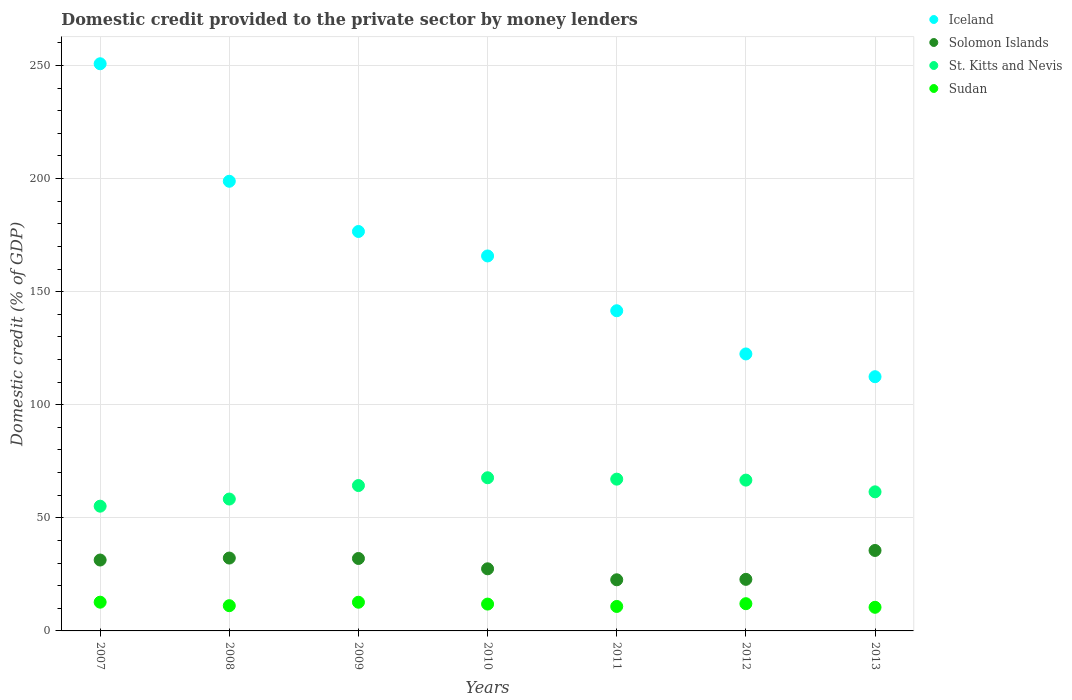Is the number of dotlines equal to the number of legend labels?
Provide a succinct answer. Yes. What is the domestic credit provided to the private sector by money lenders in Solomon Islands in 2013?
Your response must be concise. 35.57. Across all years, what is the maximum domestic credit provided to the private sector by money lenders in Iceland?
Offer a very short reply. 250.76. Across all years, what is the minimum domestic credit provided to the private sector by money lenders in Iceland?
Make the answer very short. 112.39. What is the total domestic credit provided to the private sector by money lenders in Sudan in the graph?
Your answer should be very brief. 81.71. What is the difference between the domestic credit provided to the private sector by money lenders in St. Kitts and Nevis in 2011 and that in 2012?
Offer a very short reply. 0.43. What is the difference between the domestic credit provided to the private sector by money lenders in Sudan in 2008 and the domestic credit provided to the private sector by money lenders in Solomon Islands in 2012?
Your response must be concise. -11.65. What is the average domestic credit provided to the private sector by money lenders in Sudan per year?
Your response must be concise. 11.67. In the year 2009, what is the difference between the domestic credit provided to the private sector by money lenders in St. Kitts and Nevis and domestic credit provided to the private sector by money lenders in Solomon Islands?
Give a very brief answer. 32.24. In how many years, is the domestic credit provided to the private sector by money lenders in St. Kitts and Nevis greater than 230 %?
Your answer should be very brief. 0. What is the ratio of the domestic credit provided to the private sector by money lenders in St. Kitts and Nevis in 2009 to that in 2012?
Keep it short and to the point. 0.96. Is the domestic credit provided to the private sector by money lenders in Sudan in 2010 less than that in 2012?
Your answer should be compact. Yes. Is the difference between the domestic credit provided to the private sector by money lenders in St. Kitts and Nevis in 2007 and 2012 greater than the difference between the domestic credit provided to the private sector by money lenders in Solomon Islands in 2007 and 2012?
Your response must be concise. No. What is the difference between the highest and the second highest domestic credit provided to the private sector by money lenders in Solomon Islands?
Give a very brief answer. 3.36. What is the difference between the highest and the lowest domestic credit provided to the private sector by money lenders in Solomon Islands?
Your answer should be very brief. 12.96. In how many years, is the domestic credit provided to the private sector by money lenders in St. Kitts and Nevis greater than the average domestic credit provided to the private sector by money lenders in St. Kitts and Nevis taken over all years?
Keep it short and to the point. 4. Is the sum of the domestic credit provided to the private sector by money lenders in St. Kitts and Nevis in 2008 and 2009 greater than the maximum domestic credit provided to the private sector by money lenders in Solomon Islands across all years?
Give a very brief answer. Yes. Does the domestic credit provided to the private sector by money lenders in Iceland monotonically increase over the years?
Your response must be concise. No. Is the domestic credit provided to the private sector by money lenders in Solomon Islands strictly greater than the domestic credit provided to the private sector by money lenders in St. Kitts and Nevis over the years?
Provide a short and direct response. No. What is the difference between two consecutive major ticks on the Y-axis?
Make the answer very short. 50. Does the graph contain any zero values?
Give a very brief answer. No. Where does the legend appear in the graph?
Give a very brief answer. Top right. What is the title of the graph?
Ensure brevity in your answer.  Domestic credit provided to the private sector by money lenders. What is the label or title of the Y-axis?
Keep it short and to the point. Domestic credit (% of GDP). What is the Domestic credit (% of GDP) of Iceland in 2007?
Your answer should be very brief. 250.76. What is the Domestic credit (% of GDP) of Solomon Islands in 2007?
Provide a succinct answer. 31.35. What is the Domestic credit (% of GDP) of St. Kitts and Nevis in 2007?
Provide a short and direct response. 55.15. What is the Domestic credit (% of GDP) of Sudan in 2007?
Ensure brevity in your answer.  12.71. What is the Domestic credit (% of GDP) of Iceland in 2008?
Keep it short and to the point. 198.81. What is the Domestic credit (% of GDP) in Solomon Islands in 2008?
Offer a very short reply. 32.22. What is the Domestic credit (% of GDP) in St. Kitts and Nevis in 2008?
Your response must be concise. 58.31. What is the Domestic credit (% of GDP) of Sudan in 2008?
Offer a very short reply. 11.15. What is the Domestic credit (% of GDP) in Iceland in 2009?
Your answer should be compact. 176.6. What is the Domestic credit (% of GDP) in Solomon Islands in 2009?
Provide a short and direct response. 32.03. What is the Domestic credit (% of GDP) in St. Kitts and Nevis in 2009?
Offer a terse response. 64.27. What is the Domestic credit (% of GDP) in Sudan in 2009?
Your answer should be very brief. 12.68. What is the Domestic credit (% of GDP) of Iceland in 2010?
Your answer should be compact. 165.78. What is the Domestic credit (% of GDP) in Solomon Islands in 2010?
Your response must be concise. 27.46. What is the Domestic credit (% of GDP) in St. Kitts and Nevis in 2010?
Your answer should be compact. 67.72. What is the Domestic credit (% of GDP) of Sudan in 2010?
Your answer should be very brief. 11.87. What is the Domestic credit (% of GDP) of Iceland in 2011?
Ensure brevity in your answer.  141.56. What is the Domestic credit (% of GDP) of Solomon Islands in 2011?
Provide a short and direct response. 22.61. What is the Domestic credit (% of GDP) of St. Kitts and Nevis in 2011?
Your answer should be compact. 67.1. What is the Domestic credit (% of GDP) in Sudan in 2011?
Provide a succinct answer. 10.82. What is the Domestic credit (% of GDP) in Iceland in 2012?
Your answer should be very brief. 122.46. What is the Domestic credit (% of GDP) in Solomon Islands in 2012?
Provide a short and direct response. 22.8. What is the Domestic credit (% of GDP) in St. Kitts and Nevis in 2012?
Provide a short and direct response. 66.68. What is the Domestic credit (% of GDP) of Sudan in 2012?
Make the answer very short. 12.04. What is the Domestic credit (% of GDP) in Iceland in 2013?
Ensure brevity in your answer.  112.39. What is the Domestic credit (% of GDP) in Solomon Islands in 2013?
Make the answer very short. 35.57. What is the Domestic credit (% of GDP) in St. Kitts and Nevis in 2013?
Make the answer very short. 61.49. What is the Domestic credit (% of GDP) of Sudan in 2013?
Your answer should be very brief. 10.45. Across all years, what is the maximum Domestic credit (% of GDP) in Iceland?
Make the answer very short. 250.76. Across all years, what is the maximum Domestic credit (% of GDP) in Solomon Islands?
Keep it short and to the point. 35.57. Across all years, what is the maximum Domestic credit (% of GDP) in St. Kitts and Nevis?
Keep it short and to the point. 67.72. Across all years, what is the maximum Domestic credit (% of GDP) in Sudan?
Provide a succinct answer. 12.71. Across all years, what is the minimum Domestic credit (% of GDP) in Iceland?
Offer a terse response. 112.39. Across all years, what is the minimum Domestic credit (% of GDP) in Solomon Islands?
Make the answer very short. 22.61. Across all years, what is the minimum Domestic credit (% of GDP) in St. Kitts and Nevis?
Offer a very short reply. 55.15. Across all years, what is the minimum Domestic credit (% of GDP) in Sudan?
Give a very brief answer. 10.45. What is the total Domestic credit (% of GDP) in Iceland in the graph?
Your response must be concise. 1168.37. What is the total Domestic credit (% of GDP) of Solomon Islands in the graph?
Make the answer very short. 204.04. What is the total Domestic credit (% of GDP) in St. Kitts and Nevis in the graph?
Your response must be concise. 440.72. What is the total Domestic credit (% of GDP) of Sudan in the graph?
Offer a terse response. 81.71. What is the difference between the Domestic credit (% of GDP) in Iceland in 2007 and that in 2008?
Your answer should be very brief. 51.96. What is the difference between the Domestic credit (% of GDP) of Solomon Islands in 2007 and that in 2008?
Give a very brief answer. -0.87. What is the difference between the Domestic credit (% of GDP) in St. Kitts and Nevis in 2007 and that in 2008?
Provide a short and direct response. -3.16. What is the difference between the Domestic credit (% of GDP) of Sudan in 2007 and that in 2008?
Your answer should be compact. 1.56. What is the difference between the Domestic credit (% of GDP) in Iceland in 2007 and that in 2009?
Your answer should be very brief. 74.16. What is the difference between the Domestic credit (% of GDP) of Solomon Islands in 2007 and that in 2009?
Your response must be concise. -0.68. What is the difference between the Domestic credit (% of GDP) in St. Kitts and Nevis in 2007 and that in 2009?
Make the answer very short. -9.12. What is the difference between the Domestic credit (% of GDP) in Sudan in 2007 and that in 2009?
Your answer should be compact. 0.03. What is the difference between the Domestic credit (% of GDP) of Iceland in 2007 and that in 2010?
Give a very brief answer. 84.98. What is the difference between the Domestic credit (% of GDP) of Solomon Islands in 2007 and that in 2010?
Give a very brief answer. 3.89. What is the difference between the Domestic credit (% of GDP) in St. Kitts and Nevis in 2007 and that in 2010?
Provide a short and direct response. -12.57. What is the difference between the Domestic credit (% of GDP) of Sudan in 2007 and that in 2010?
Provide a succinct answer. 0.84. What is the difference between the Domestic credit (% of GDP) in Iceland in 2007 and that in 2011?
Offer a very short reply. 109.2. What is the difference between the Domestic credit (% of GDP) in Solomon Islands in 2007 and that in 2011?
Your answer should be compact. 8.74. What is the difference between the Domestic credit (% of GDP) of St. Kitts and Nevis in 2007 and that in 2011?
Your answer should be compact. -11.95. What is the difference between the Domestic credit (% of GDP) in Sudan in 2007 and that in 2011?
Keep it short and to the point. 1.89. What is the difference between the Domestic credit (% of GDP) of Iceland in 2007 and that in 2012?
Make the answer very short. 128.3. What is the difference between the Domestic credit (% of GDP) of Solomon Islands in 2007 and that in 2012?
Give a very brief answer. 8.55. What is the difference between the Domestic credit (% of GDP) of St. Kitts and Nevis in 2007 and that in 2012?
Your answer should be very brief. -11.53. What is the difference between the Domestic credit (% of GDP) in Sudan in 2007 and that in 2012?
Ensure brevity in your answer.  0.67. What is the difference between the Domestic credit (% of GDP) of Iceland in 2007 and that in 2013?
Your answer should be compact. 138.37. What is the difference between the Domestic credit (% of GDP) of Solomon Islands in 2007 and that in 2013?
Your answer should be compact. -4.22. What is the difference between the Domestic credit (% of GDP) in St. Kitts and Nevis in 2007 and that in 2013?
Your answer should be very brief. -6.34. What is the difference between the Domestic credit (% of GDP) in Sudan in 2007 and that in 2013?
Make the answer very short. 2.26. What is the difference between the Domestic credit (% of GDP) in Iceland in 2008 and that in 2009?
Your answer should be compact. 22.2. What is the difference between the Domestic credit (% of GDP) in Solomon Islands in 2008 and that in 2009?
Offer a terse response. 0.19. What is the difference between the Domestic credit (% of GDP) in St. Kitts and Nevis in 2008 and that in 2009?
Your answer should be very brief. -5.96. What is the difference between the Domestic credit (% of GDP) in Sudan in 2008 and that in 2009?
Your response must be concise. -1.53. What is the difference between the Domestic credit (% of GDP) in Iceland in 2008 and that in 2010?
Give a very brief answer. 33.02. What is the difference between the Domestic credit (% of GDP) in Solomon Islands in 2008 and that in 2010?
Your answer should be very brief. 4.75. What is the difference between the Domestic credit (% of GDP) of St. Kitts and Nevis in 2008 and that in 2010?
Your answer should be compact. -9.41. What is the difference between the Domestic credit (% of GDP) of Sudan in 2008 and that in 2010?
Offer a very short reply. -0.71. What is the difference between the Domestic credit (% of GDP) of Iceland in 2008 and that in 2011?
Provide a short and direct response. 57.25. What is the difference between the Domestic credit (% of GDP) of Solomon Islands in 2008 and that in 2011?
Ensure brevity in your answer.  9.61. What is the difference between the Domestic credit (% of GDP) in St. Kitts and Nevis in 2008 and that in 2011?
Your answer should be compact. -8.8. What is the difference between the Domestic credit (% of GDP) of Sudan in 2008 and that in 2011?
Offer a terse response. 0.33. What is the difference between the Domestic credit (% of GDP) of Iceland in 2008 and that in 2012?
Provide a succinct answer. 76.35. What is the difference between the Domestic credit (% of GDP) of Solomon Islands in 2008 and that in 2012?
Your answer should be very brief. 9.42. What is the difference between the Domestic credit (% of GDP) of St. Kitts and Nevis in 2008 and that in 2012?
Provide a short and direct response. -8.37. What is the difference between the Domestic credit (% of GDP) in Sudan in 2008 and that in 2012?
Your answer should be very brief. -0.89. What is the difference between the Domestic credit (% of GDP) in Iceland in 2008 and that in 2013?
Offer a terse response. 86.41. What is the difference between the Domestic credit (% of GDP) of Solomon Islands in 2008 and that in 2013?
Make the answer very short. -3.36. What is the difference between the Domestic credit (% of GDP) in St. Kitts and Nevis in 2008 and that in 2013?
Your response must be concise. -3.19. What is the difference between the Domestic credit (% of GDP) of Sudan in 2008 and that in 2013?
Make the answer very short. 0.71. What is the difference between the Domestic credit (% of GDP) of Iceland in 2009 and that in 2010?
Provide a succinct answer. 10.82. What is the difference between the Domestic credit (% of GDP) of Solomon Islands in 2009 and that in 2010?
Ensure brevity in your answer.  4.57. What is the difference between the Domestic credit (% of GDP) in St. Kitts and Nevis in 2009 and that in 2010?
Keep it short and to the point. -3.45. What is the difference between the Domestic credit (% of GDP) of Sudan in 2009 and that in 2010?
Provide a succinct answer. 0.82. What is the difference between the Domestic credit (% of GDP) of Iceland in 2009 and that in 2011?
Make the answer very short. 35.04. What is the difference between the Domestic credit (% of GDP) of Solomon Islands in 2009 and that in 2011?
Give a very brief answer. 9.42. What is the difference between the Domestic credit (% of GDP) of St. Kitts and Nevis in 2009 and that in 2011?
Offer a terse response. -2.83. What is the difference between the Domestic credit (% of GDP) in Sudan in 2009 and that in 2011?
Provide a succinct answer. 1.86. What is the difference between the Domestic credit (% of GDP) in Iceland in 2009 and that in 2012?
Ensure brevity in your answer.  54.14. What is the difference between the Domestic credit (% of GDP) in Solomon Islands in 2009 and that in 2012?
Make the answer very short. 9.23. What is the difference between the Domestic credit (% of GDP) in St. Kitts and Nevis in 2009 and that in 2012?
Offer a terse response. -2.4. What is the difference between the Domestic credit (% of GDP) of Sudan in 2009 and that in 2012?
Ensure brevity in your answer.  0.64. What is the difference between the Domestic credit (% of GDP) of Iceland in 2009 and that in 2013?
Offer a very short reply. 64.21. What is the difference between the Domestic credit (% of GDP) of Solomon Islands in 2009 and that in 2013?
Provide a short and direct response. -3.54. What is the difference between the Domestic credit (% of GDP) in St. Kitts and Nevis in 2009 and that in 2013?
Make the answer very short. 2.78. What is the difference between the Domestic credit (% of GDP) in Sudan in 2009 and that in 2013?
Give a very brief answer. 2.24. What is the difference between the Domestic credit (% of GDP) of Iceland in 2010 and that in 2011?
Provide a short and direct response. 24.22. What is the difference between the Domestic credit (% of GDP) of Solomon Islands in 2010 and that in 2011?
Ensure brevity in your answer.  4.85. What is the difference between the Domestic credit (% of GDP) in St. Kitts and Nevis in 2010 and that in 2011?
Give a very brief answer. 0.61. What is the difference between the Domestic credit (% of GDP) in Sudan in 2010 and that in 2011?
Provide a succinct answer. 1.04. What is the difference between the Domestic credit (% of GDP) in Iceland in 2010 and that in 2012?
Your answer should be very brief. 43.32. What is the difference between the Domestic credit (% of GDP) in Solomon Islands in 2010 and that in 2012?
Provide a short and direct response. 4.66. What is the difference between the Domestic credit (% of GDP) in St. Kitts and Nevis in 2010 and that in 2012?
Provide a succinct answer. 1.04. What is the difference between the Domestic credit (% of GDP) of Sudan in 2010 and that in 2012?
Make the answer very short. -0.17. What is the difference between the Domestic credit (% of GDP) in Iceland in 2010 and that in 2013?
Your response must be concise. 53.39. What is the difference between the Domestic credit (% of GDP) in Solomon Islands in 2010 and that in 2013?
Your answer should be compact. -8.11. What is the difference between the Domestic credit (% of GDP) of St. Kitts and Nevis in 2010 and that in 2013?
Provide a short and direct response. 6.22. What is the difference between the Domestic credit (% of GDP) of Sudan in 2010 and that in 2013?
Give a very brief answer. 1.42. What is the difference between the Domestic credit (% of GDP) of Iceland in 2011 and that in 2012?
Ensure brevity in your answer.  19.1. What is the difference between the Domestic credit (% of GDP) in Solomon Islands in 2011 and that in 2012?
Offer a very short reply. -0.19. What is the difference between the Domestic credit (% of GDP) of St. Kitts and Nevis in 2011 and that in 2012?
Ensure brevity in your answer.  0.43. What is the difference between the Domestic credit (% of GDP) in Sudan in 2011 and that in 2012?
Provide a succinct answer. -1.22. What is the difference between the Domestic credit (% of GDP) of Iceland in 2011 and that in 2013?
Give a very brief answer. 29.17. What is the difference between the Domestic credit (% of GDP) of Solomon Islands in 2011 and that in 2013?
Ensure brevity in your answer.  -12.96. What is the difference between the Domestic credit (% of GDP) in St. Kitts and Nevis in 2011 and that in 2013?
Provide a short and direct response. 5.61. What is the difference between the Domestic credit (% of GDP) in Sudan in 2011 and that in 2013?
Make the answer very short. 0.37. What is the difference between the Domestic credit (% of GDP) of Iceland in 2012 and that in 2013?
Offer a terse response. 10.07. What is the difference between the Domestic credit (% of GDP) in Solomon Islands in 2012 and that in 2013?
Provide a short and direct response. -12.77. What is the difference between the Domestic credit (% of GDP) in St. Kitts and Nevis in 2012 and that in 2013?
Ensure brevity in your answer.  5.18. What is the difference between the Domestic credit (% of GDP) of Sudan in 2012 and that in 2013?
Your answer should be compact. 1.59. What is the difference between the Domestic credit (% of GDP) of Iceland in 2007 and the Domestic credit (% of GDP) of Solomon Islands in 2008?
Provide a succinct answer. 218.55. What is the difference between the Domestic credit (% of GDP) of Iceland in 2007 and the Domestic credit (% of GDP) of St. Kitts and Nevis in 2008?
Your response must be concise. 192.46. What is the difference between the Domestic credit (% of GDP) in Iceland in 2007 and the Domestic credit (% of GDP) in Sudan in 2008?
Offer a very short reply. 239.61. What is the difference between the Domestic credit (% of GDP) of Solomon Islands in 2007 and the Domestic credit (% of GDP) of St. Kitts and Nevis in 2008?
Ensure brevity in your answer.  -26.96. What is the difference between the Domestic credit (% of GDP) in Solomon Islands in 2007 and the Domestic credit (% of GDP) in Sudan in 2008?
Ensure brevity in your answer.  20.2. What is the difference between the Domestic credit (% of GDP) in St. Kitts and Nevis in 2007 and the Domestic credit (% of GDP) in Sudan in 2008?
Your response must be concise. 44. What is the difference between the Domestic credit (% of GDP) of Iceland in 2007 and the Domestic credit (% of GDP) of Solomon Islands in 2009?
Ensure brevity in your answer.  218.73. What is the difference between the Domestic credit (% of GDP) of Iceland in 2007 and the Domestic credit (% of GDP) of St. Kitts and Nevis in 2009?
Offer a terse response. 186.49. What is the difference between the Domestic credit (% of GDP) in Iceland in 2007 and the Domestic credit (% of GDP) in Sudan in 2009?
Offer a very short reply. 238.08. What is the difference between the Domestic credit (% of GDP) in Solomon Islands in 2007 and the Domestic credit (% of GDP) in St. Kitts and Nevis in 2009?
Provide a short and direct response. -32.92. What is the difference between the Domestic credit (% of GDP) of Solomon Islands in 2007 and the Domestic credit (% of GDP) of Sudan in 2009?
Your answer should be compact. 18.67. What is the difference between the Domestic credit (% of GDP) in St. Kitts and Nevis in 2007 and the Domestic credit (% of GDP) in Sudan in 2009?
Offer a terse response. 42.47. What is the difference between the Domestic credit (% of GDP) in Iceland in 2007 and the Domestic credit (% of GDP) in Solomon Islands in 2010?
Your response must be concise. 223.3. What is the difference between the Domestic credit (% of GDP) in Iceland in 2007 and the Domestic credit (% of GDP) in St. Kitts and Nevis in 2010?
Provide a short and direct response. 183.05. What is the difference between the Domestic credit (% of GDP) of Iceland in 2007 and the Domestic credit (% of GDP) of Sudan in 2010?
Your answer should be compact. 238.9. What is the difference between the Domestic credit (% of GDP) of Solomon Islands in 2007 and the Domestic credit (% of GDP) of St. Kitts and Nevis in 2010?
Ensure brevity in your answer.  -36.37. What is the difference between the Domestic credit (% of GDP) of Solomon Islands in 2007 and the Domestic credit (% of GDP) of Sudan in 2010?
Provide a succinct answer. 19.48. What is the difference between the Domestic credit (% of GDP) in St. Kitts and Nevis in 2007 and the Domestic credit (% of GDP) in Sudan in 2010?
Provide a short and direct response. 43.28. What is the difference between the Domestic credit (% of GDP) in Iceland in 2007 and the Domestic credit (% of GDP) in Solomon Islands in 2011?
Your answer should be compact. 228.15. What is the difference between the Domestic credit (% of GDP) of Iceland in 2007 and the Domestic credit (% of GDP) of St. Kitts and Nevis in 2011?
Make the answer very short. 183.66. What is the difference between the Domestic credit (% of GDP) in Iceland in 2007 and the Domestic credit (% of GDP) in Sudan in 2011?
Make the answer very short. 239.94. What is the difference between the Domestic credit (% of GDP) of Solomon Islands in 2007 and the Domestic credit (% of GDP) of St. Kitts and Nevis in 2011?
Provide a succinct answer. -35.76. What is the difference between the Domestic credit (% of GDP) in Solomon Islands in 2007 and the Domestic credit (% of GDP) in Sudan in 2011?
Offer a terse response. 20.53. What is the difference between the Domestic credit (% of GDP) of St. Kitts and Nevis in 2007 and the Domestic credit (% of GDP) of Sudan in 2011?
Your answer should be very brief. 44.33. What is the difference between the Domestic credit (% of GDP) in Iceland in 2007 and the Domestic credit (% of GDP) in Solomon Islands in 2012?
Offer a terse response. 227.96. What is the difference between the Domestic credit (% of GDP) of Iceland in 2007 and the Domestic credit (% of GDP) of St. Kitts and Nevis in 2012?
Offer a terse response. 184.09. What is the difference between the Domestic credit (% of GDP) in Iceland in 2007 and the Domestic credit (% of GDP) in Sudan in 2012?
Offer a terse response. 238.72. What is the difference between the Domestic credit (% of GDP) in Solomon Islands in 2007 and the Domestic credit (% of GDP) in St. Kitts and Nevis in 2012?
Your answer should be compact. -35.33. What is the difference between the Domestic credit (% of GDP) in Solomon Islands in 2007 and the Domestic credit (% of GDP) in Sudan in 2012?
Give a very brief answer. 19.31. What is the difference between the Domestic credit (% of GDP) of St. Kitts and Nevis in 2007 and the Domestic credit (% of GDP) of Sudan in 2012?
Offer a very short reply. 43.11. What is the difference between the Domestic credit (% of GDP) of Iceland in 2007 and the Domestic credit (% of GDP) of Solomon Islands in 2013?
Keep it short and to the point. 215.19. What is the difference between the Domestic credit (% of GDP) of Iceland in 2007 and the Domestic credit (% of GDP) of St. Kitts and Nevis in 2013?
Your answer should be compact. 189.27. What is the difference between the Domestic credit (% of GDP) of Iceland in 2007 and the Domestic credit (% of GDP) of Sudan in 2013?
Offer a very short reply. 240.32. What is the difference between the Domestic credit (% of GDP) in Solomon Islands in 2007 and the Domestic credit (% of GDP) in St. Kitts and Nevis in 2013?
Provide a short and direct response. -30.15. What is the difference between the Domestic credit (% of GDP) of Solomon Islands in 2007 and the Domestic credit (% of GDP) of Sudan in 2013?
Your answer should be very brief. 20.9. What is the difference between the Domestic credit (% of GDP) in St. Kitts and Nevis in 2007 and the Domestic credit (% of GDP) in Sudan in 2013?
Your answer should be very brief. 44.7. What is the difference between the Domestic credit (% of GDP) of Iceland in 2008 and the Domestic credit (% of GDP) of Solomon Islands in 2009?
Ensure brevity in your answer.  166.77. What is the difference between the Domestic credit (% of GDP) in Iceland in 2008 and the Domestic credit (% of GDP) in St. Kitts and Nevis in 2009?
Offer a terse response. 134.53. What is the difference between the Domestic credit (% of GDP) of Iceland in 2008 and the Domestic credit (% of GDP) of Sudan in 2009?
Offer a very short reply. 186.12. What is the difference between the Domestic credit (% of GDP) in Solomon Islands in 2008 and the Domestic credit (% of GDP) in St. Kitts and Nevis in 2009?
Offer a very short reply. -32.05. What is the difference between the Domestic credit (% of GDP) in Solomon Islands in 2008 and the Domestic credit (% of GDP) in Sudan in 2009?
Offer a terse response. 19.54. What is the difference between the Domestic credit (% of GDP) in St. Kitts and Nevis in 2008 and the Domestic credit (% of GDP) in Sudan in 2009?
Offer a terse response. 45.63. What is the difference between the Domestic credit (% of GDP) of Iceland in 2008 and the Domestic credit (% of GDP) of Solomon Islands in 2010?
Ensure brevity in your answer.  171.34. What is the difference between the Domestic credit (% of GDP) of Iceland in 2008 and the Domestic credit (% of GDP) of St. Kitts and Nevis in 2010?
Your response must be concise. 131.09. What is the difference between the Domestic credit (% of GDP) in Iceland in 2008 and the Domestic credit (% of GDP) in Sudan in 2010?
Your response must be concise. 186.94. What is the difference between the Domestic credit (% of GDP) of Solomon Islands in 2008 and the Domestic credit (% of GDP) of St. Kitts and Nevis in 2010?
Ensure brevity in your answer.  -35.5. What is the difference between the Domestic credit (% of GDP) of Solomon Islands in 2008 and the Domestic credit (% of GDP) of Sudan in 2010?
Keep it short and to the point. 20.35. What is the difference between the Domestic credit (% of GDP) of St. Kitts and Nevis in 2008 and the Domestic credit (% of GDP) of Sudan in 2010?
Your answer should be very brief. 46.44. What is the difference between the Domestic credit (% of GDP) of Iceland in 2008 and the Domestic credit (% of GDP) of Solomon Islands in 2011?
Offer a terse response. 176.2. What is the difference between the Domestic credit (% of GDP) in Iceland in 2008 and the Domestic credit (% of GDP) in St. Kitts and Nevis in 2011?
Offer a terse response. 131.7. What is the difference between the Domestic credit (% of GDP) of Iceland in 2008 and the Domestic credit (% of GDP) of Sudan in 2011?
Give a very brief answer. 187.99. What is the difference between the Domestic credit (% of GDP) in Solomon Islands in 2008 and the Domestic credit (% of GDP) in St. Kitts and Nevis in 2011?
Offer a very short reply. -34.89. What is the difference between the Domestic credit (% of GDP) in Solomon Islands in 2008 and the Domestic credit (% of GDP) in Sudan in 2011?
Provide a short and direct response. 21.4. What is the difference between the Domestic credit (% of GDP) of St. Kitts and Nevis in 2008 and the Domestic credit (% of GDP) of Sudan in 2011?
Offer a very short reply. 47.49. What is the difference between the Domestic credit (% of GDP) in Iceland in 2008 and the Domestic credit (% of GDP) in Solomon Islands in 2012?
Give a very brief answer. 176.01. What is the difference between the Domestic credit (% of GDP) of Iceland in 2008 and the Domestic credit (% of GDP) of St. Kitts and Nevis in 2012?
Make the answer very short. 132.13. What is the difference between the Domestic credit (% of GDP) in Iceland in 2008 and the Domestic credit (% of GDP) in Sudan in 2012?
Make the answer very short. 186.77. What is the difference between the Domestic credit (% of GDP) of Solomon Islands in 2008 and the Domestic credit (% of GDP) of St. Kitts and Nevis in 2012?
Your response must be concise. -34.46. What is the difference between the Domestic credit (% of GDP) of Solomon Islands in 2008 and the Domestic credit (% of GDP) of Sudan in 2012?
Your response must be concise. 20.18. What is the difference between the Domestic credit (% of GDP) of St. Kitts and Nevis in 2008 and the Domestic credit (% of GDP) of Sudan in 2012?
Provide a short and direct response. 46.27. What is the difference between the Domestic credit (% of GDP) in Iceland in 2008 and the Domestic credit (% of GDP) in Solomon Islands in 2013?
Your answer should be compact. 163.23. What is the difference between the Domestic credit (% of GDP) of Iceland in 2008 and the Domestic credit (% of GDP) of St. Kitts and Nevis in 2013?
Provide a succinct answer. 137.31. What is the difference between the Domestic credit (% of GDP) of Iceland in 2008 and the Domestic credit (% of GDP) of Sudan in 2013?
Your answer should be compact. 188.36. What is the difference between the Domestic credit (% of GDP) in Solomon Islands in 2008 and the Domestic credit (% of GDP) in St. Kitts and Nevis in 2013?
Provide a short and direct response. -29.28. What is the difference between the Domestic credit (% of GDP) in Solomon Islands in 2008 and the Domestic credit (% of GDP) in Sudan in 2013?
Provide a short and direct response. 21.77. What is the difference between the Domestic credit (% of GDP) of St. Kitts and Nevis in 2008 and the Domestic credit (% of GDP) of Sudan in 2013?
Make the answer very short. 47.86. What is the difference between the Domestic credit (% of GDP) in Iceland in 2009 and the Domestic credit (% of GDP) in Solomon Islands in 2010?
Provide a short and direct response. 149.14. What is the difference between the Domestic credit (% of GDP) of Iceland in 2009 and the Domestic credit (% of GDP) of St. Kitts and Nevis in 2010?
Give a very brief answer. 108.88. What is the difference between the Domestic credit (% of GDP) in Iceland in 2009 and the Domestic credit (% of GDP) in Sudan in 2010?
Offer a very short reply. 164.74. What is the difference between the Domestic credit (% of GDP) in Solomon Islands in 2009 and the Domestic credit (% of GDP) in St. Kitts and Nevis in 2010?
Your response must be concise. -35.69. What is the difference between the Domestic credit (% of GDP) of Solomon Islands in 2009 and the Domestic credit (% of GDP) of Sudan in 2010?
Your answer should be compact. 20.17. What is the difference between the Domestic credit (% of GDP) in St. Kitts and Nevis in 2009 and the Domestic credit (% of GDP) in Sudan in 2010?
Your answer should be compact. 52.41. What is the difference between the Domestic credit (% of GDP) in Iceland in 2009 and the Domestic credit (% of GDP) in Solomon Islands in 2011?
Provide a short and direct response. 153.99. What is the difference between the Domestic credit (% of GDP) of Iceland in 2009 and the Domestic credit (% of GDP) of St. Kitts and Nevis in 2011?
Ensure brevity in your answer.  109.5. What is the difference between the Domestic credit (% of GDP) in Iceland in 2009 and the Domestic credit (% of GDP) in Sudan in 2011?
Keep it short and to the point. 165.78. What is the difference between the Domestic credit (% of GDP) in Solomon Islands in 2009 and the Domestic credit (% of GDP) in St. Kitts and Nevis in 2011?
Make the answer very short. -35.07. What is the difference between the Domestic credit (% of GDP) of Solomon Islands in 2009 and the Domestic credit (% of GDP) of Sudan in 2011?
Make the answer very short. 21.21. What is the difference between the Domestic credit (% of GDP) in St. Kitts and Nevis in 2009 and the Domestic credit (% of GDP) in Sudan in 2011?
Ensure brevity in your answer.  53.45. What is the difference between the Domestic credit (% of GDP) of Iceland in 2009 and the Domestic credit (% of GDP) of Solomon Islands in 2012?
Your answer should be compact. 153.8. What is the difference between the Domestic credit (% of GDP) of Iceland in 2009 and the Domestic credit (% of GDP) of St. Kitts and Nevis in 2012?
Offer a very short reply. 109.93. What is the difference between the Domestic credit (% of GDP) in Iceland in 2009 and the Domestic credit (% of GDP) in Sudan in 2012?
Your response must be concise. 164.56. What is the difference between the Domestic credit (% of GDP) of Solomon Islands in 2009 and the Domestic credit (% of GDP) of St. Kitts and Nevis in 2012?
Give a very brief answer. -34.64. What is the difference between the Domestic credit (% of GDP) in Solomon Islands in 2009 and the Domestic credit (% of GDP) in Sudan in 2012?
Your response must be concise. 19.99. What is the difference between the Domestic credit (% of GDP) of St. Kitts and Nevis in 2009 and the Domestic credit (% of GDP) of Sudan in 2012?
Keep it short and to the point. 52.23. What is the difference between the Domestic credit (% of GDP) of Iceland in 2009 and the Domestic credit (% of GDP) of Solomon Islands in 2013?
Provide a succinct answer. 141.03. What is the difference between the Domestic credit (% of GDP) in Iceland in 2009 and the Domestic credit (% of GDP) in St. Kitts and Nevis in 2013?
Your answer should be very brief. 115.11. What is the difference between the Domestic credit (% of GDP) in Iceland in 2009 and the Domestic credit (% of GDP) in Sudan in 2013?
Offer a terse response. 166.16. What is the difference between the Domestic credit (% of GDP) in Solomon Islands in 2009 and the Domestic credit (% of GDP) in St. Kitts and Nevis in 2013?
Offer a very short reply. -29.46. What is the difference between the Domestic credit (% of GDP) in Solomon Islands in 2009 and the Domestic credit (% of GDP) in Sudan in 2013?
Make the answer very short. 21.59. What is the difference between the Domestic credit (% of GDP) in St. Kitts and Nevis in 2009 and the Domestic credit (% of GDP) in Sudan in 2013?
Make the answer very short. 53.83. What is the difference between the Domestic credit (% of GDP) in Iceland in 2010 and the Domestic credit (% of GDP) in Solomon Islands in 2011?
Give a very brief answer. 143.17. What is the difference between the Domestic credit (% of GDP) in Iceland in 2010 and the Domestic credit (% of GDP) in St. Kitts and Nevis in 2011?
Your answer should be very brief. 98.68. What is the difference between the Domestic credit (% of GDP) in Iceland in 2010 and the Domestic credit (% of GDP) in Sudan in 2011?
Offer a very short reply. 154.96. What is the difference between the Domestic credit (% of GDP) in Solomon Islands in 2010 and the Domestic credit (% of GDP) in St. Kitts and Nevis in 2011?
Offer a very short reply. -39.64. What is the difference between the Domestic credit (% of GDP) in Solomon Islands in 2010 and the Domestic credit (% of GDP) in Sudan in 2011?
Ensure brevity in your answer.  16.64. What is the difference between the Domestic credit (% of GDP) in St. Kitts and Nevis in 2010 and the Domestic credit (% of GDP) in Sudan in 2011?
Your answer should be compact. 56.9. What is the difference between the Domestic credit (% of GDP) of Iceland in 2010 and the Domestic credit (% of GDP) of Solomon Islands in 2012?
Keep it short and to the point. 142.98. What is the difference between the Domestic credit (% of GDP) of Iceland in 2010 and the Domestic credit (% of GDP) of St. Kitts and Nevis in 2012?
Give a very brief answer. 99.11. What is the difference between the Domestic credit (% of GDP) in Iceland in 2010 and the Domestic credit (% of GDP) in Sudan in 2012?
Give a very brief answer. 153.75. What is the difference between the Domestic credit (% of GDP) of Solomon Islands in 2010 and the Domestic credit (% of GDP) of St. Kitts and Nevis in 2012?
Offer a very short reply. -39.21. What is the difference between the Domestic credit (% of GDP) of Solomon Islands in 2010 and the Domestic credit (% of GDP) of Sudan in 2012?
Make the answer very short. 15.42. What is the difference between the Domestic credit (% of GDP) of St. Kitts and Nevis in 2010 and the Domestic credit (% of GDP) of Sudan in 2012?
Keep it short and to the point. 55.68. What is the difference between the Domestic credit (% of GDP) in Iceland in 2010 and the Domestic credit (% of GDP) in Solomon Islands in 2013?
Your answer should be compact. 130.21. What is the difference between the Domestic credit (% of GDP) in Iceland in 2010 and the Domestic credit (% of GDP) in St. Kitts and Nevis in 2013?
Offer a terse response. 104.29. What is the difference between the Domestic credit (% of GDP) of Iceland in 2010 and the Domestic credit (% of GDP) of Sudan in 2013?
Your answer should be compact. 155.34. What is the difference between the Domestic credit (% of GDP) in Solomon Islands in 2010 and the Domestic credit (% of GDP) in St. Kitts and Nevis in 2013?
Make the answer very short. -34.03. What is the difference between the Domestic credit (% of GDP) in Solomon Islands in 2010 and the Domestic credit (% of GDP) in Sudan in 2013?
Provide a succinct answer. 17.02. What is the difference between the Domestic credit (% of GDP) of St. Kitts and Nevis in 2010 and the Domestic credit (% of GDP) of Sudan in 2013?
Provide a short and direct response. 57.27. What is the difference between the Domestic credit (% of GDP) of Iceland in 2011 and the Domestic credit (% of GDP) of Solomon Islands in 2012?
Provide a short and direct response. 118.76. What is the difference between the Domestic credit (% of GDP) in Iceland in 2011 and the Domestic credit (% of GDP) in St. Kitts and Nevis in 2012?
Ensure brevity in your answer.  74.88. What is the difference between the Domestic credit (% of GDP) in Iceland in 2011 and the Domestic credit (% of GDP) in Sudan in 2012?
Provide a short and direct response. 129.52. What is the difference between the Domestic credit (% of GDP) in Solomon Islands in 2011 and the Domestic credit (% of GDP) in St. Kitts and Nevis in 2012?
Provide a succinct answer. -44.07. What is the difference between the Domestic credit (% of GDP) in Solomon Islands in 2011 and the Domestic credit (% of GDP) in Sudan in 2012?
Offer a very short reply. 10.57. What is the difference between the Domestic credit (% of GDP) in St. Kitts and Nevis in 2011 and the Domestic credit (% of GDP) in Sudan in 2012?
Your response must be concise. 55.07. What is the difference between the Domestic credit (% of GDP) of Iceland in 2011 and the Domestic credit (% of GDP) of Solomon Islands in 2013?
Provide a succinct answer. 105.99. What is the difference between the Domestic credit (% of GDP) of Iceland in 2011 and the Domestic credit (% of GDP) of St. Kitts and Nevis in 2013?
Provide a succinct answer. 80.07. What is the difference between the Domestic credit (% of GDP) in Iceland in 2011 and the Domestic credit (% of GDP) in Sudan in 2013?
Ensure brevity in your answer.  131.11. What is the difference between the Domestic credit (% of GDP) of Solomon Islands in 2011 and the Domestic credit (% of GDP) of St. Kitts and Nevis in 2013?
Make the answer very short. -38.88. What is the difference between the Domestic credit (% of GDP) in Solomon Islands in 2011 and the Domestic credit (% of GDP) in Sudan in 2013?
Offer a very short reply. 12.16. What is the difference between the Domestic credit (% of GDP) of St. Kitts and Nevis in 2011 and the Domestic credit (% of GDP) of Sudan in 2013?
Offer a very short reply. 56.66. What is the difference between the Domestic credit (% of GDP) in Iceland in 2012 and the Domestic credit (% of GDP) in Solomon Islands in 2013?
Give a very brief answer. 86.89. What is the difference between the Domestic credit (% of GDP) in Iceland in 2012 and the Domestic credit (% of GDP) in St. Kitts and Nevis in 2013?
Your answer should be very brief. 60.97. What is the difference between the Domestic credit (% of GDP) of Iceland in 2012 and the Domestic credit (% of GDP) of Sudan in 2013?
Provide a succinct answer. 112.01. What is the difference between the Domestic credit (% of GDP) in Solomon Islands in 2012 and the Domestic credit (% of GDP) in St. Kitts and Nevis in 2013?
Provide a succinct answer. -38.69. What is the difference between the Domestic credit (% of GDP) of Solomon Islands in 2012 and the Domestic credit (% of GDP) of Sudan in 2013?
Provide a succinct answer. 12.35. What is the difference between the Domestic credit (% of GDP) in St. Kitts and Nevis in 2012 and the Domestic credit (% of GDP) in Sudan in 2013?
Your answer should be very brief. 56.23. What is the average Domestic credit (% of GDP) in Iceland per year?
Provide a succinct answer. 166.91. What is the average Domestic credit (% of GDP) in Solomon Islands per year?
Your answer should be very brief. 29.15. What is the average Domestic credit (% of GDP) in St. Kitts and Nevis per year?
Your answer should be compact. 62.96. What is the average Domestic credit (% of GDP) of Sudan per year?
Give a very brief answer. 11.67. In the year 2007, what is the difference between the Domestic credit (% of GDP) of Iceland and Domestic credit (% of GDP) of Solomon Islands?
Give a very brief answer. 219.41. In the year 2007, what is the difference between the Domestic credit (% of GDP) of Iceland and Domestic credit (% of GDP) of St. Kitts and Nevis?
Provide a succinct answer. 195.61. In the year 2007, what is the difference between the Domestic credit (% of GDP) in Iceland and Domestic credit (% of GDP) in Sudan?
Offer a very short reply. 238.06. In the year 2007, what is the difference between the Domestic credit (% of GDP) of Solomon Islands and Domestic credit (% of GDP) of St. Kitts and Nevis?
Provide a short and direct response. -23.8. In the year 2007, what is the difference between the Domestic credit (% of GDP) in Solomon Islands and Domestic credit (% of GDP) in Sudan?
Give a very brief answer. 18.64. In the year 2007, what is the difference between the Domestic credit (% of GDP) of St. Kitts and Nevis and Domestic credit (% of GDP) of Sudan?
Ensure brevity in your answer.  42.44. In the year 2008, what is the difference between the Domestic credit (% of GDP) of Iceland and Domestic credit (% of GDP) of Solomon Islands?
Make the answer very short. 166.59. In the year 2008, what is the difference between the Domestic credit (% of GDP) in Iceland and Domestic credit (% of GDP) in St. Kitts and Nevis?
Keep it short and to the point. 140.5. In the year 2008, what is the difference between the Domestic credit (% of GDP) in Iceland and Domestic credit (% of GDP) in Sudan?
Provide a succinct answer. 187.65. In the year 2008, what is the difference between the Domestic credit (% of GDP) of Solomon Islands and Domestic credit (% of GDP) of St. Kitts and Nevis?
Give a very brief answer. -26.09. In the year 2008, what is the difference between the Domestic credit (% of GDP) of Solomon Islands and Domestic credit (% of GDP) of Sudan?
Provide a short and direct response. 21.06. In the year 2008, what is the difference between the Domestic credit (% of GDP) in St. Kitts and Nevis and Domestic credit (% of GDP) in Sudan?
Ensure brevity in your answer.  47.16. In the year 2009, what is the difference between the Domestic credit (% of GDP) of Iceland and Domestic credit (% of GDP) of Solomon Islands?
Give a very brief answer. 144.57. In the year 2009, what is the difference between the Domestic credit (% of GDP) of Iceland and Domestic credit (% of GDP) of St. Kitts and Nevis?
Your answer should be compact. 112.33. In the year 2009, what is the difference between the Domestic credit (% of GDP) in Iceland and Domestic credit (% of GDP) in Sudan?
Provide a succinct answer. 163.92. In the year 2009, what is the difference between the Domestic credit (% of GDP) in Solomon Islands and Domestic credit (% of GDP) in St. Kitts and Nevis?
Provide a succinct answer. -32.24. In the year 2009, what is the difference between the Domestic credit (% of GDP) of Solomon Islands and Domestic credit (% of GDP) of Sudan?
Ensure brevity in your answer.  19.35. In the year 2009, what is the difference between the Domestic credit (% of GDP) in St. Kitts and Nevis and Domestic credit (% of GDP) in Sudan?
Provide a short and direct response. 51.59. In the year 2010, what is the difference between the Domestic credit (% of GDP) in Iceland and Domestic credit (% of GDP) in Solomon Islands?
Keep it short and to the point. 138.32. In the year 2010, what is the difference between the Domestic credit (% of GDP) in Iceland and Domestic credit (% of GDP) in St. Kitts and Nevis?
Keep it short and to the point. 98.07. In the year 2010, what is the difference between the Domestic credit (% of GDP) of Iceland and Domestic credit (% of GDP) of Sudan?
Your answer should be very brief. 153.92. In the year 2010, what is the difference between the Domestic credit (% of GDP) of Solomon Islands and Domestic credit (% of GDP) of St. Kitts and Nevis?
Provide a succinct answer. -40.25. In the year 2010, what is the difference between the Domestic credit (% of GDP) of Solomon Islands and Domestic credit (% of GDP) of Sudan?
Ensure brevity in your answer.  15.6. In the year 2010, what is the difference between the Domestic credit (% of GDP) in St. Kitts and Nevis and Domestic credit (% of GDP) in Sudan?
Give a very brief answer. 55.85. In the year 2011, what is the difference between the Domestic credit (% of GDP) in Iceland and Domestic credit (% of GDP) in Solomon Islands?
Provide a short and direct response. 118.95. In the year 2011, what is the difference between the Domestic credit (% of GDP) of Iceland and Domestic credit (% of GDP) of St. Kitts and Nevis?
Ensure brevity in your answer.  74.46. In the year 2011, what is the difference between the Domestic credit (% of GDP) of Iceland and Domestic credit (% of GDP) of Sudan?
Provide a succinct answer. 130.74. In the year 2011, what is the difference between the Domestic credit (% of GDP) of Solomon Islands and Domestic credit (% of GDP) of St. Kitts and Nevis?
Keep it short and to the point. -44.49. In the year 2011, what is the difference between the Domestic credit (% of GDP) of Solomon Islands and Domestic credit (% of GDP) of Sudan?
Offer a terse response. 11.79. In the year 2011, what is the difference between the Domestic credit (% of GDP) in St. Kitts and Nevis and Domestic credit (% of GDP) in Sudan?
Offer a very short reply. 56.28. In the year 2012, what is the difference between the Domestic credit (% of GDP) of Iceland and Domestic credit (% of GDP) of Solomon Islands?
Keep it short and to the point. 99.66. In the year 2012, what is the difference between the Domestic credit (% of GDP) in Iceland and Domestic credit (% of GDP) in St. Kitts and Nevis?
Provide a succinct answer. 55.78. In the year 2012, what is the difference between the Domestic credit (% of GDP) in Iceland and Domestic credit (% of GDP) in Sudan?
Give a very brief answer. 110.42. In the year 2012, what is the difference between the Domestic credit (% of GDP) of Solomon Islands and Domestic credit (% of GDP) of St. Kitts and Nevis?
Offer a terse response. -43.88. In the year 2012, what is the difference between the Domestic credit (% of GDP) in Solomon Islands and Domestic credit (% of GDP) in Sudan?
Make the answer very short. 10.76. In the year 2012, what is the difference between the Domestic credit (% of GDP) in St. Kitts and Nevis and Domestic credit (% of GDP) in Sudan?
Provide a succinct answer. 54.64. In the year 2013, what is the difference between the Domestic credit (% of GDP) in Iceland and Domestic credit (% of GDP) in Solomon Islands?
Provide a succinct answer. 76.82. In the year 2013, what is the difference between the Domestic credit (% of GDP) in Iceland and Domestic credit (% of GDP) in St. Kitts and Nevis?
Provide a short and direct response. 50.9. In the year 2013, what is the difference between the Domestic credit (% of GDP) in Iceland and Domestic credit (% of GDP) in Sudan?
Offer a terse response. 101.95. In the year 2013, what is the difference between the Domestic credit (% of GDP) of Solomon Islands and Domestic credit (% of GDP) of St. Kitts and Nevis?
Offer a very short reply. -25.92. In the year 2013, what is the difference between the Domestic credit (% of GDP) in Solomon Islands and Domestic credit (% of GDP) in Sudan?
Provide a succinct answer. 25.13. In the year 2013, what is the difference between the Domestic credit (% of GDP) in St. Kitts and Nevis and Domestic credit (% of GDP) in Sudan?
Your answer should be very brief. 51.05. What is the ratio of the Domestic credit (% of GDP) in Iceland in 2007 to that in 2008?
Make the answer very short. 1.26. What is the ratio of the Domestic credit (% of GDP) of Solomon Islands in 2007 to that in 2008?
Provide a short and direct response. 0.97. What is the ratio of the Domestic credit (% of GDP) in St. Kitts and Nevis in 2007 to that in 2008?
Keep it short and to the point. 0.95. What is the ratio of the Domestic credit (% of GDP) in Sudan in 2007 to that in 2008?
Your response must be concise. 1.14. What is the ratio of the Domestic credit (% of GDP) of Iceland in 2007 to that in 2009?
Keep it short and to the point. 1.42. What is the ratio of the Domestic credit (% of GDP) of Solomon Islands in 2007 to that in 2009?
Provide a short and direct response. 0.98. What is the ratio of the Domestic credit (% of GDP) of St. Kitts and Nevis in 2007 to that in 2009?
Provide a short and direct response. 0.86. What is the ratio of the Domestic credit (% of GDP) of Sudan in 2007 to that in 2009?
Your answer should be very brief. 1. What is the ratio of the Domestic credit (% of GDP) in Iceland in 2007 to that in 2010?
Your answer should be very brief. 1.51. What is the ratio of the Domestic credit (% of GDP) in Solomon Islands in 2007 to that in 2010?
Provide a succinct answer. 1.14. What is the ratio of the Domestic credit (% of GDP) in St. Kitts and Nevis in 2007 to that in 2010?
Offer a terse response. 0.81. What is the ratio of the Domestic credit (% of GDP) of Sudan in 2007 to that in 2010?
Offer a very short reply. 1.07. What is the ratio of the Domestic credit (% of GDP) in Iceland in 2007 to that in 2011?
Give a very brief answer. 1.77. What is the ratio of the Domestic credit (% of GDP) of Solomon Islands in 2007 to that in 2011?
Provide a short and direct response. 1.39. What is the ratio of the Domestic credit (% of GDP) of St. Kitts and Nevis in 2007 to that in 2011?
Provide a short and direct response. 0.82. What is the ratio of the Domestic credit (% of GDP) of Sudan in 2007 to that in 2011?
Provide a short and direct response. 1.17. What is the ratio of the Domestic credit (% of GDP) in Iceland in 2007 to that in 2012?
Offer a terse response. 2.05. What is the ratio of the Domestic credit (% of GDP) in Solomon Islands in 2007 to that in 2012?
Your answer should be very brief. 1.37. What is the ratio of the Domestic credit (% of GDP) of St. Kitts and Nevis in 2007 to that in 2012?
Your answer should be very brief. 0.83. What is the ratio of the Domestic credit (% of GDP) of Sudan in 2007 to that in 2012?
Provide a short and direct response. 1.06. What is the ratio of the Domestic credit (% of GDP) of Iceland in 2007 to that in 2013?
Your answer should be very brief. 2.23. What is the ratio of the Domestic credit (% of GDP) in Solomon Islands in 2007 to that in 2013?
Make the answer very short. 0.88. What is the ratio of the Domestic credit (% of GDP) of St. Kitts and Nevis in 2007 to that in 2013?
Your answer should be compact. 0.9. What is the ratio of the Domestic credit (% of GDP) of Sudan in 2007 to that in 2013?
Provide a short and direct response. 1.22. What is the ratio of the Domestic credit (% of GDP) in Iceland in 2008 to that in 2009?
Give a very brief answer. 1.13. What is the ratio of the Domestic credit (% of GDP) of Solomon Islands in 2008 to that in 2009?
Your answer should be compact. 1.01. What is the ratio of the Domestic credit (% of GDP) of St. Kitts and Nevis in 2008 to that in 2009?
Make the answer very short. 0.91. What is the ratio of the Domestic credit (% of GDP) in Sudan in 2008 to that in 2009?
Provide a short and direct response. 0.88. What is the ratio of the Domestic credit (% of GDP) in Iceland in 2008 to that in 2010?
Your answer should be compact. 1.2. What is the ratio of the Domestic credit (% of GDP) in Solomon Islands in 2008 to that in 2010?
Give a very brief answer. 1.17. What is the ratio of the Domestic credit (% of GDP) of St. Kitts and Nevis in 2008 to that in 2010?
Offer a very short reply. 0.86. What is the ratio of the Domestic credit (% of GDP) of Sudan in 2008 to that in 2010?
Keep it short and to the point. 0.94. What is the ratio of the Domestic credit (% of GDP) in Iceland in 2008 to that in 2011?
Your answer should be compact. 1.4. What is the ratio of the Domestic credit (% of GDP) in Solomon Islands in 2008 to that in 2011?
Keep it short and to the point. 1.42. What is the ratio of the Domestic credit (% of GDP) of St. Kitts and Nevis in 2008 to that in 2011?
Provide a succinct answer. 0.87. What is the ratio of the Domestic credit (% of GDP) in Sudan in 2008 to that in 2011?
Make the answer very short. 1.03. What is the ratio of the Domestic credit (% of GDP) in Iceland in 2008 to that in 2012?
Offer a terse response. 1.62. What is the ratio of the Domestic credit (% of GDP) in Solomon Islands in 2008 to that in 2012?
Provide a short and direct response. 1.41. What is the ratio of the Domestic credit (% of GDP) of St. Kitts and Nevis in 2008 to that in 2012?
Provide a succinct answer. 0.87. What is the ratio of the Domestic credit (% of GDP) of Sudan in 2008 to that in 2012?
Your answer should be very brief. 0.93. What is the ratio of the Domestic credit (% of GDP) of Iceland in 2008 to that in 2013?
Your answer should be compact. 1.77. What is the ratio of the Domestic credit (% of GDP) in Solomon Islands in 2008 to that in 2013?
Your answer should be very brief. 0.91. What is the ratio of the Domestic credit (% of GDP) in St. Kitts and Nevis in 2008 to that in 2013?
Provide a short and direct response. 0.95. What is the ratio of the Domestic credit (% of GDP) in Sudan in 2008 to that in 2013?
Your answer should be compact. 1.07. What is the ratio of the Domestic credit (% of GDP) of Iceland in 2009 to that in 2010?
Your answer should be compact. 1.07. What is the ratio of the Domestic credit (% of GDP) of Solomon Islands in 2009 to that in 2010?
Ensure brevity in your answer.  1.17. What is the ratio of the Domestic credit (% of GDP) in St. Kitts and Nevis in 2009 to that in 2010?
Give a very brief answer. 0.95. What is the ratio of the Domestic credit (% of GDP) in Sudan in 2009 to that in 2010?
Provide a succinct answer. 1.07. What is the ratio of the Domestic credit (% of GDP) of Iceland in 2009 to that in 2011?
Your answer should be compact. 1.25. What is the ratio of the Domestic credit (% of GDP) of Solomon Islands in 2009 to that in 2011?
Give a very brief answer. 1.42. What is the ratio of the Domestic credit (% of GDP) in St. Kitts and Nevis in 2009 to that in 2011?
Provide a short and direct response. 0.96. What is the ratio of the Domestic credit (% of GDP) of Sudan in 2009 to that in 2011?
Offer a terse response. 1.17. What is the ratio of the Domestic credit (% of GDP) of Iceland in 2009 to that in 2012?
Provide a succinct answer. 1.44. What is the ratio of the Domestic credit (% of GDP) of Solomon Islands in 2009 to that in 2012?
Ensure brevity in your answer.  1.4. What is the ratio of the Domestic credit (% of GDP) in St. Kitts and Nevis in 2009 to that in 2012?
Your response must be concise. 0.96. What is the ratio of the Domestic credit (% of GDP) in Sudan in 2009 to that in 2012?
Ensure brevity in your answer.  1.05. What is the ratio of the Domestic credit (% of GDP) of Iceland in 2009 to that in 2013?
Provide a short and direct response. 1.57. What is the ratio of the Domestic credit (% of GDP) of Solomon Islands in 2009 to that in 2013?
Your answer should be compact. 0.9. What is the ratio of the Domestic credit (% of GDP) in St. Kitts and Nevis in 2009 to that in 2013?
Provide a succinct answer. 1.05. What is the ratio of the Domestic credit (% of GDP) in Sudan in 2009 to that in 2013?
Provide a succinct answer. 1.21. What is the ratio of the Domestic credit (% of GDP) of Iceland in 2010 to that in 2011?
Ensure brevity in your answer.  1.17. What is the ratio of the Domestic credit (% of GDP) in Solomon Islands in 2010 to that in 2011?
Your response must be concise. 1.21. What is the ratio of the Domestic credit (% of GDP) in St. Kitts and Nevis in 2010 to that in 2011?
Ensure brevity in your answer.  1.01. What is the ratio of the Domestic credit (% of GDP) of Sudan in 2010 to that in 2011?
Give a very brief answer. 1.1. What is the ratio of the Domestic credit (% of GDP) in Iceland in 2010 to that in 2012?
Offer a terse response. 1.35. What is the ratio of the Domestic credit (% of GDP) in Solomon Islands in 2010 to that in 2012?
Keep it short and to the point. 1.2. What is the ratio of the Domestic credit (% of GDP) of St. Kitts and Nevis in 2010 to that in 2012?
Give a very brief answer. 1.02. What is the ratio of the Domestic credit (% of GDP) of Sudan in 2010 to that in 2012?
Offer a very short reply. 0.99. What is the ratio of the Domestic credit (% of GDP) in Iceland in 2010 to that in 2013?
Your answer should be compact. 1.48. What is the ratio of the Domestic credit (% of GDP) in Solomon Islands in 2010 to that in 2013?
Give a very brief answer. 0.77. What is the ratio of the Domestic credit (% of GDP) of St. Kitts and Nevis in 2010 to that in 2013?
Keep it short and to the point. 1.1. What is the ratio of the Domestic credit (% of GDP) of Sudan in 2010 to that in 2013?
Provide a short and direct response. 1.14. What is the ratio of the Domestic credit (% of GDP) of Iceland in 2011 to that in 2012?
Offer a terse response. 1.16. What is the ratio of the Domestic credit (% of GDP) of St. Kitts and Nevis in 2011 to that in 2012?
Provide a succinct answer. 1.01. What is the ratio of the Domestic credit (% of GDP) of Sudan in 2011 to that in 2012?
Offer a very short reply. 0.9. What is the ratio of the Domestic credit (% of GDP) of Iceland in 2011 to that in 2013?
Your answer should be compact. 1.26. What is the ratio of the Domestic credit (% of GDP) in Solomon Islands in 2011 to that in 2013?
Keep it short and to the point. 0.64. What is the ratio of the Domestic credit (% of GDP) in St. Kitts and Nevis in 2011 to that in 2013?
Offer a very short reply. 1.09. What is the ratio of the Domestic credit (% of GDP) of Sudan in 2011 to that in 2013?
Provide a short and direct response. 1.04. What is the ratio of the Domestic credit (% of GDP) of Iceland in 2012 to that in 2013?
Make the answer very short. 1.09. What is the ratio of the Domestic credit (% of GDP) of Solomon Islands in 2012 to that in 2013?
Your answer should be very brief. 0.64. What is the ratio of the Domestic credit (% of GDP) in St. Kitts and Nevis in 2012 to that in 2013?
Keep it short and to the point. 1.08. What is the ratio of the Domestic credit (% of GDP) of Sudan in 2012 to that in 2013?
Keep it short and to the point. 1.15. What is the difference between the highest and the second highest Domestic credit (% of GDP) of Iceland?
Your answer should be very brief. 51.96. What is the difference between the highest and the second highest Domestic credit (% of GDP) in Solomon Islands?
Provide a succinct answer. 3.36. What is the difference between the highest and the second highest Domestic credit (% of GDP) of St. Kitts and Nevis?
Offer a very short reply. 0.61. What is the difference between the highest and the second highest Domestic credit (% of GDP) of Sudan?
Your answer should be very brief. 0.03. What is the difference between the highest and the lowest Domestic credit (% of GDP) in Iceland?
Your response must be concise. 138.37. What is the difference between the highest and the lowest Domestic credit (% of GDP) in Solomon Islands?
Ensure brevity in your answer.  12.96. What is the difference between the highest and the lowest Domestic credit (% of GDP) in St. Kitts and Nevis?
Give a very brief answer. 12.57. What is the difference between the highest and the lowest Domestic credit (% of GDP) in Sudan?
Give a very brief answer. 2.26. 